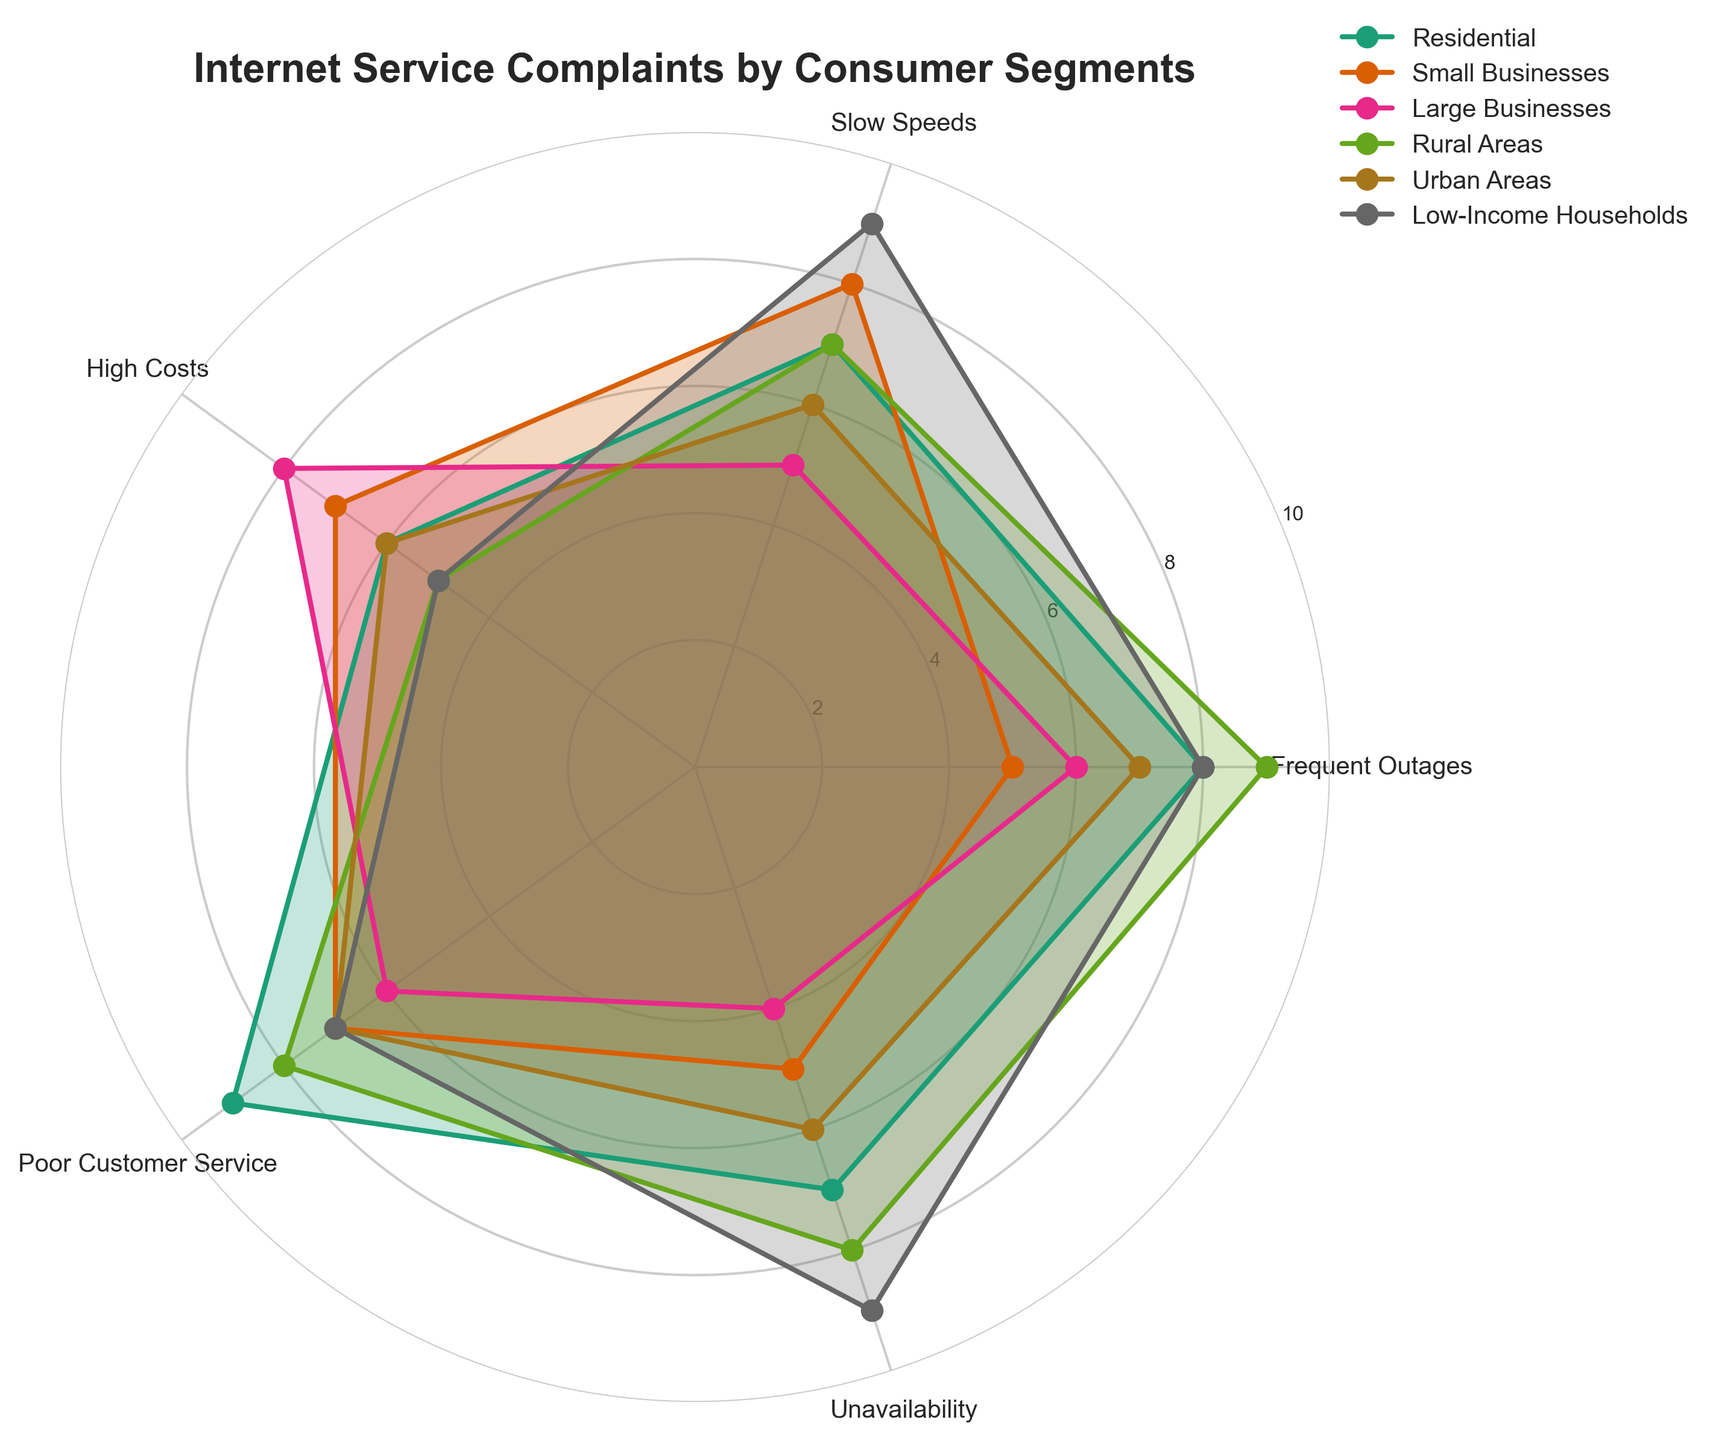What is the title of the figure? The title is prominently displayed at the top of the figure and summarizes its content.
Answer: Internet Service Complaints by Consumer Segments Which consumer segments are displayed in the plot? The legend lists the different consumer segments shown in the plot.
Answer: Residential, Small Businesses, Large Businesses, Rural Areas, Urban Areas, Low-Income Households Which consumer segment reports the most frequent outages? By observing the "Frequent Outages" axis, the segment with the largest value is identified.
Answer: Rural Areas On which complaint category does Low-Income Households have the highest score? By following the line for Low-Income Households, the highest spikes show the complaints.
Answer: Slow Speeds and Unavailability How does the frequency of poor customer service complaints compare between Residential and Rural Areas? Look at the values for "Poor Customer Service" for both segments, and compare them.
Answer: Both have a score of 8 What is the average complaint value for Slow Speeds across all consumer segments? Sum the values for Slow Speeds and divide by the number of segments. Calculation: (7 + 8 + 5 + 7 + 6 + 9) / 6 = 42 / 6 = 7
Answer: 7 Which consumer segment reports fewer high-cost complaints: Small Businesses or Large Businesses? Compare the "High Costs" values for Small Businesses and Large Businesses.
Answer: Small Businesses What is the range of complaint scores reported by Urban Areas for all categories? Find the difference between the highest and lowest complaint scores for Urban Areas. Highest = 7, Lowest = 6, Range = 7 - 6
Answer: 1 Which categories indicate the most concern for Small Businesses? The highest spikes in the radar plot for Small Businesses indicate the most concerns.
Answer: Slow Speeds and High Costs Are there any categories in which both Residential and Large Businesses show equal levels of complaints? Compare the values for each category between Residential and Large Businesses.
Answer: No 